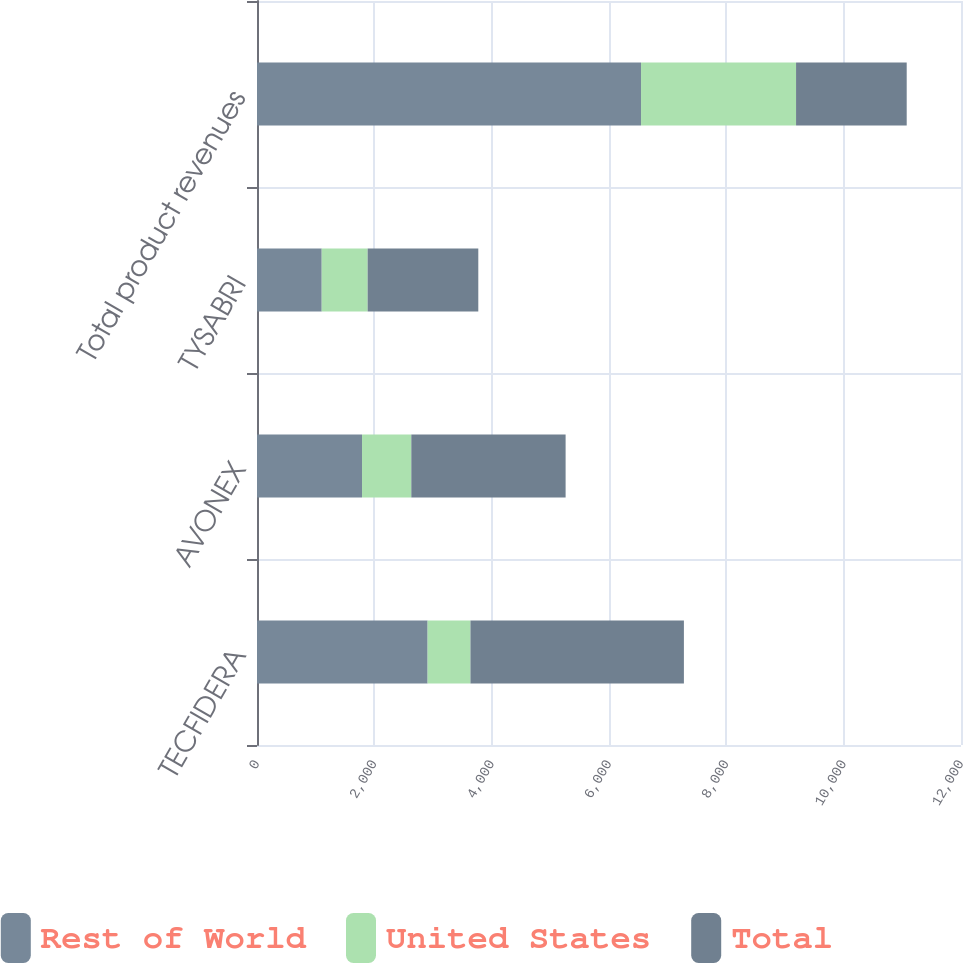Convert chart to OTSL. <chart><loc_0><loc_0><loc_500><loc_500><stacked_bar_chart><ecel><fcel>TECFIDERA<fcel>AVONEX<fcel>TYSABRI<fcel>Total product revenues<nl><fcel>Rest of World<fcel>2908.2<fcel>1790.2<fcel>1103.1<fcel>6545.8<nl><fcel>United States<fcel>730.2<fcel>840<fcel>783<fcel>2642.7<nl><fcel>Total<fcel>3638.4<fcel>2630.2<fcel>1886.1<fcel>1886.1<nl></chart> 